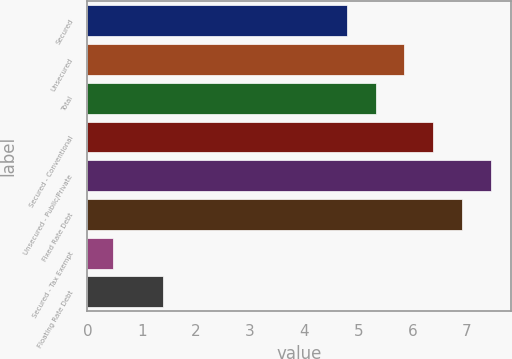<chart> <loc_0><loc_0><loc_500><loc_500><bar_chart><fcel>Secured<fcel>Unsecured<fcel>Total<fcel>Secured - Conventional<fcel>Unsecured - Public/Private<fcel>Fixed Rate Debt<fcel>Secured - Tax Exempt<fcel>Floating Rate Debt<nl><fcel>4.79<fcel>5.85<fcel>5.32<fcel>6.38<fcel>7.44<fcel>6.91<fcel>0.48<fcel>1.39<nl></chart> 